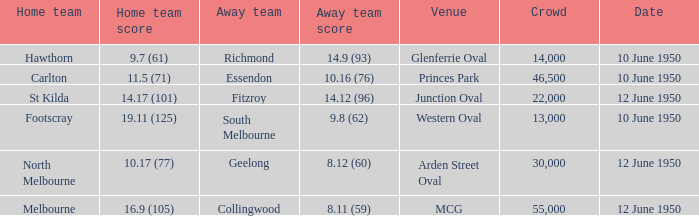What was the crowd when the VFL played MCG? 55000.0. 